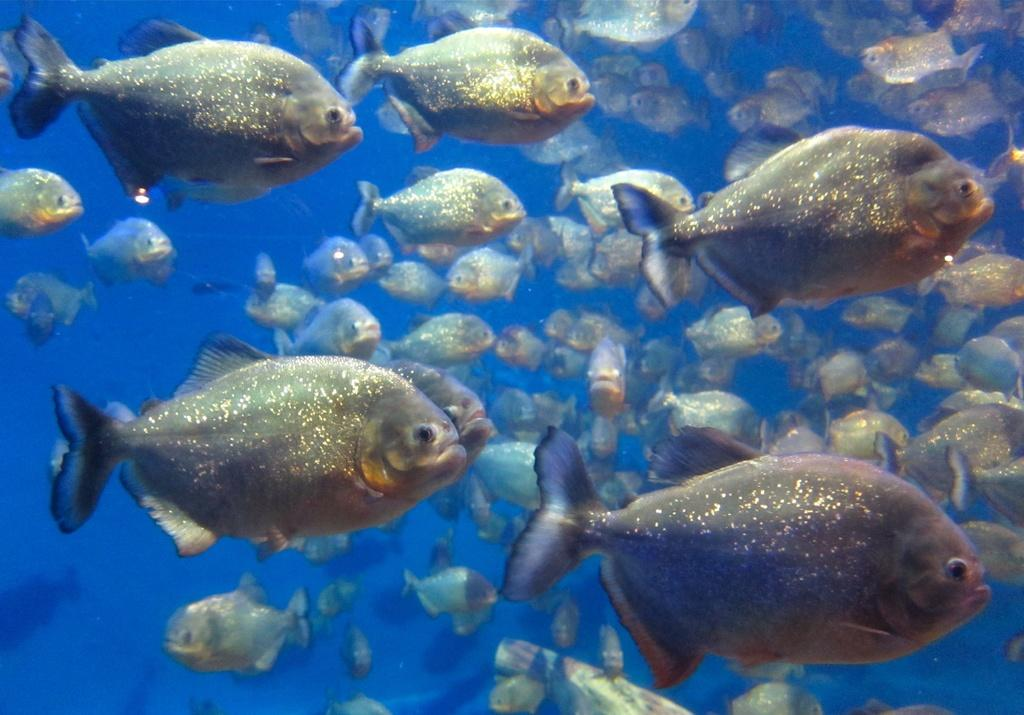What type of animals are present in the image? There is a group of fishes in the image. Where are the fishes located? The fishes are in the water. What type of drum can be seen in the image? There is no drum present in the image; it features a group of fishes in the water. What is the range of the school in the image? There is no school present in the image, and the concept of "range" is not applicable to a group of fishes. 